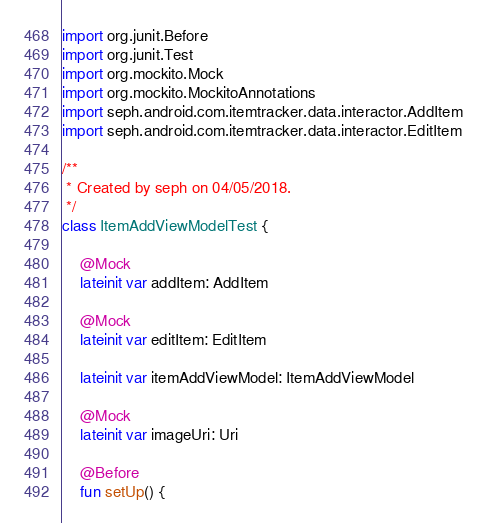Convert code to text. <code><loc_0><loc_0><loc_500><loc_500><_Kotlin_>import org.junit.Before
import org.junit.Test
import org.mockito.Mock
import org.mockito.MockitoAnnotations
import seph.android.com.itemtracker.data.interactor.AddItem
import seph.android.com.itemtracker.data.interactor.EditItem

/**
 * Created by seph on 04/05/2018.
 */
class ItemAddViewModelTest {

    @Mock
    lateinit var addItem: AddItem

    @Mock
    lateinit var editItem: EditItem

    lateinit var itemAddViewModel: ItemAddViewModel

    @Mock
    lateinit var imageUri: Uri

    @Before
    fun setUp() {</code> 